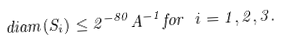Convert formula to latex. <formula><loc_0><loc_0><loc_500><loc_500>d i a m ( S _ { i } ) \leq 2 ^ { - 8 0 } A ^ { - 1 } f o r \ i = 1 , 2 , 3 .</formula> 